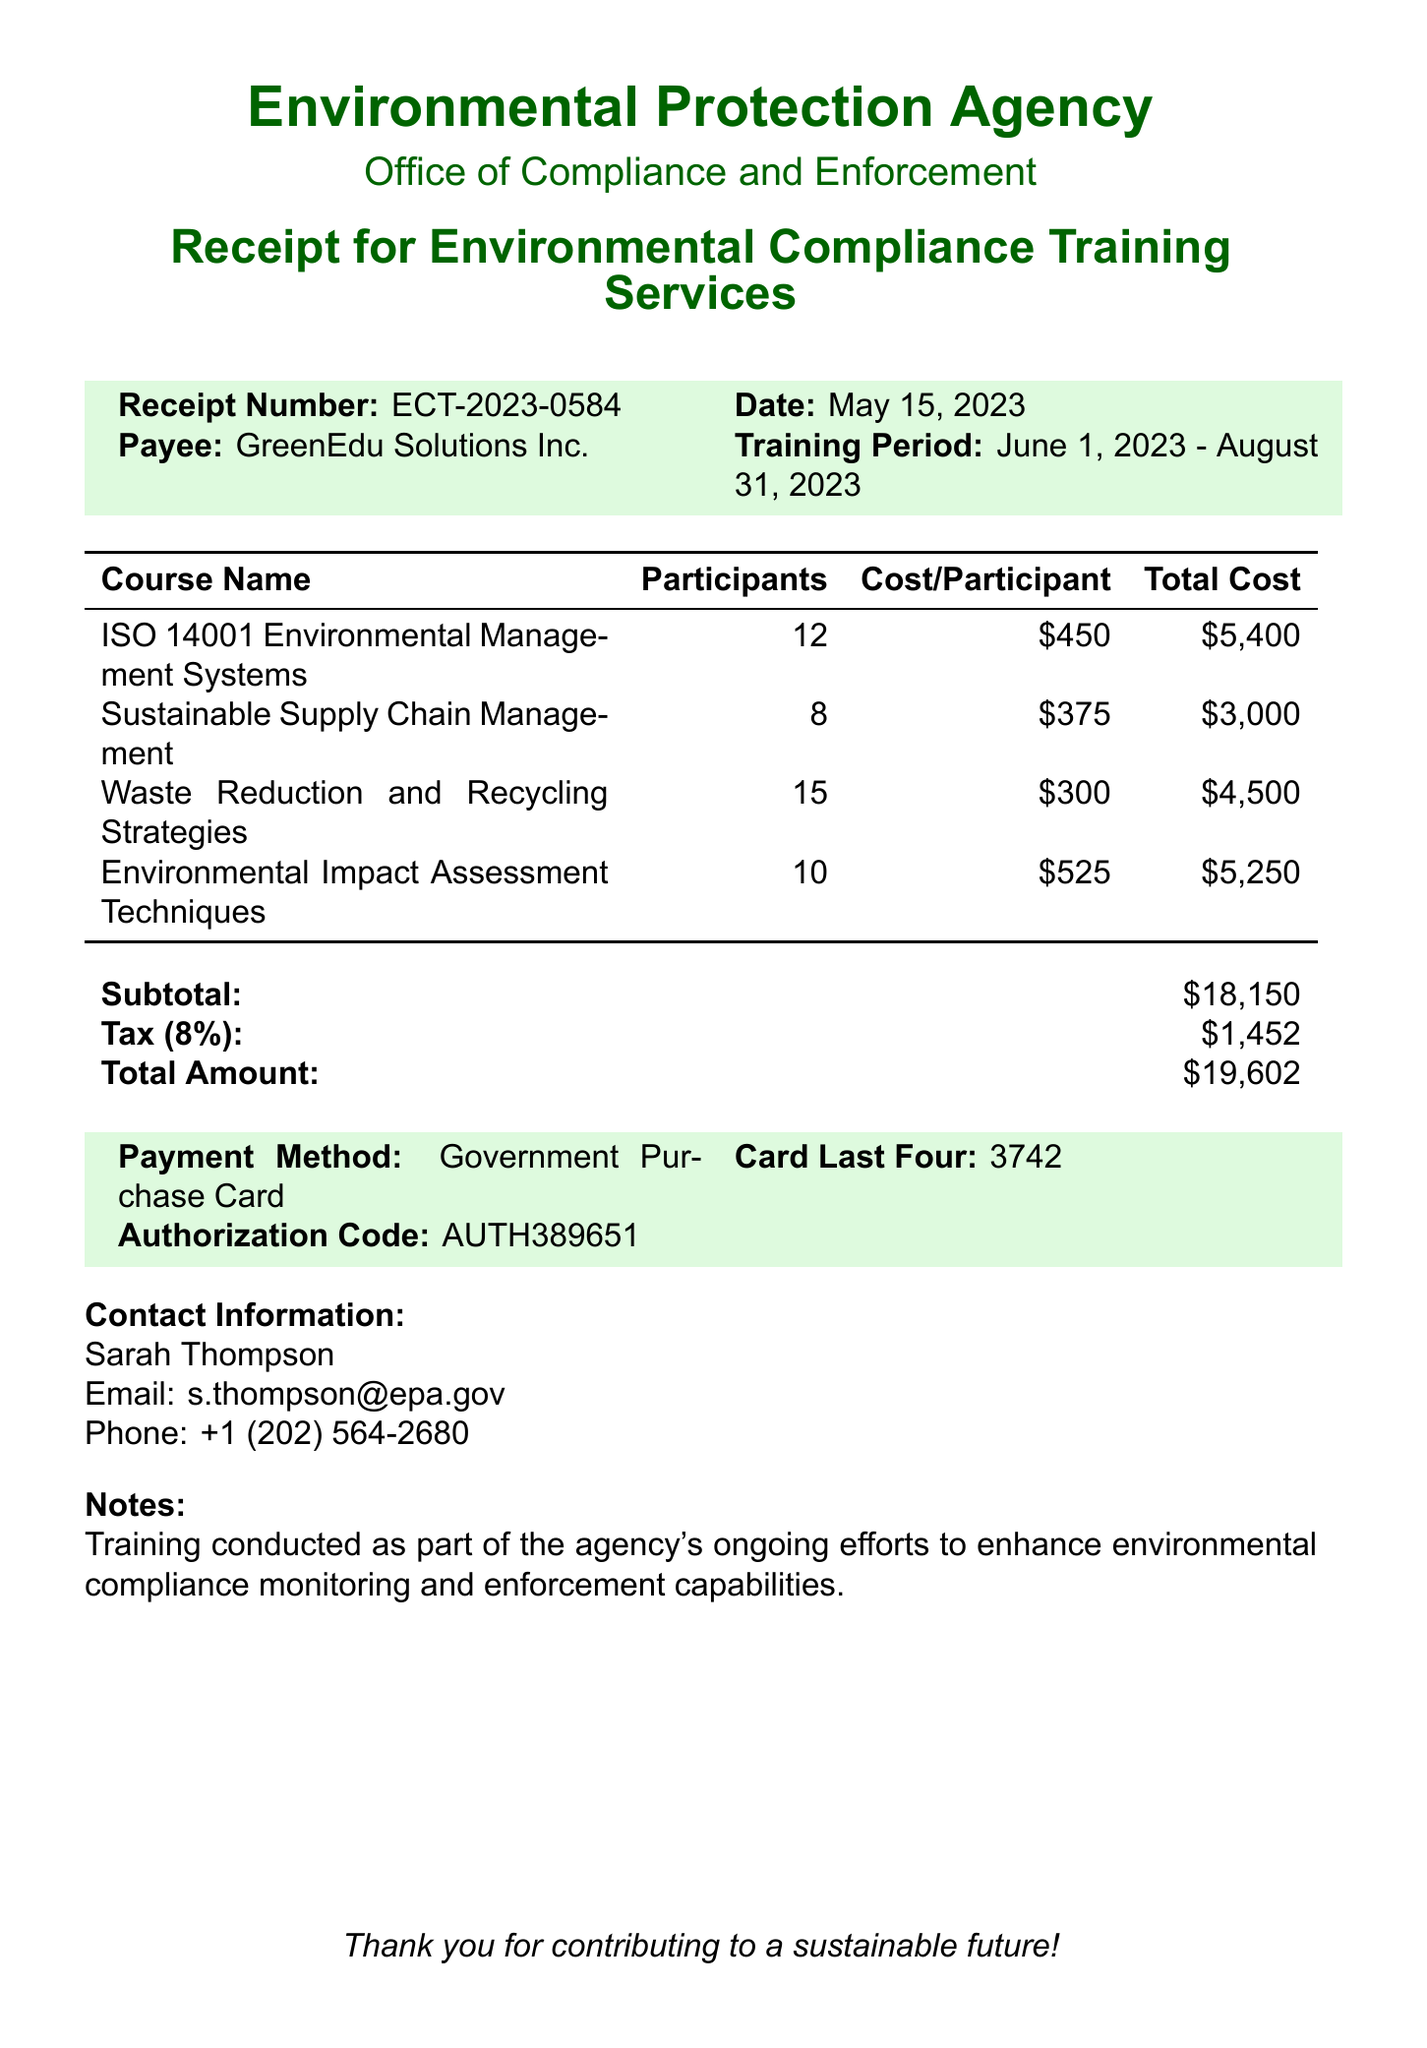What is the receipt number? The receipt number is explicitly stated in the document as ECT-2023-0584.
Answer: ECT-2023-0584 What is the date of the transaction? The date of the transaction is provided in the document as May 15, 2023.
Answer: May 15, 2023 Who is the payee for the training services? The payee's name is listed as GreenEdu Solutions Inc. in the document.
Answer: GreenEdu Solutions Inc What is the total amount charged? The total amount charged is clearly indicated in the document as $19,602.
Answer: $19,602 How many participants attended the "Waste Reduction and Recycling Strategies" course? The number of participants for that course is mentioned in the document as 15.
Answer: 15 What course had the highest cost per participant? The course with the highest cost per participant is detailed as "Environmental Impact Assessment Techniques" at $525.
Answer: Environmental Impact Assessment Techniques What is the tax rate applied to this transaction? The document states that the tax rate is 8 percent.
Answer: 8% What payment method was used for this transaction? The payment method is specified in the document as Government Purchase Card.
Answer: Government Purchase Card Who is the contact person for this transaction? The contact person is indicated in the document as Sarah Thompson.
Answer: Sarah Thompson 